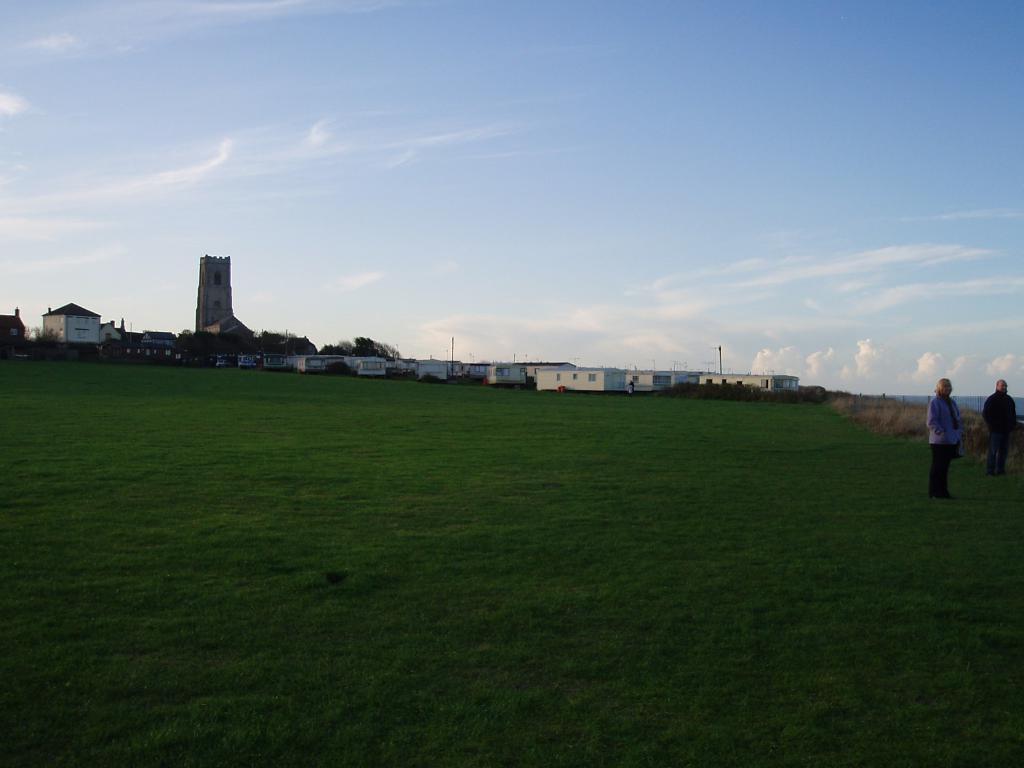How would you summarize this image in a sentence or two? In this image we can see the buildings and also the houses. We can also see the trees and also the grass. On the right we can see two persons standing. In the background we can see the sky with some clouds. 